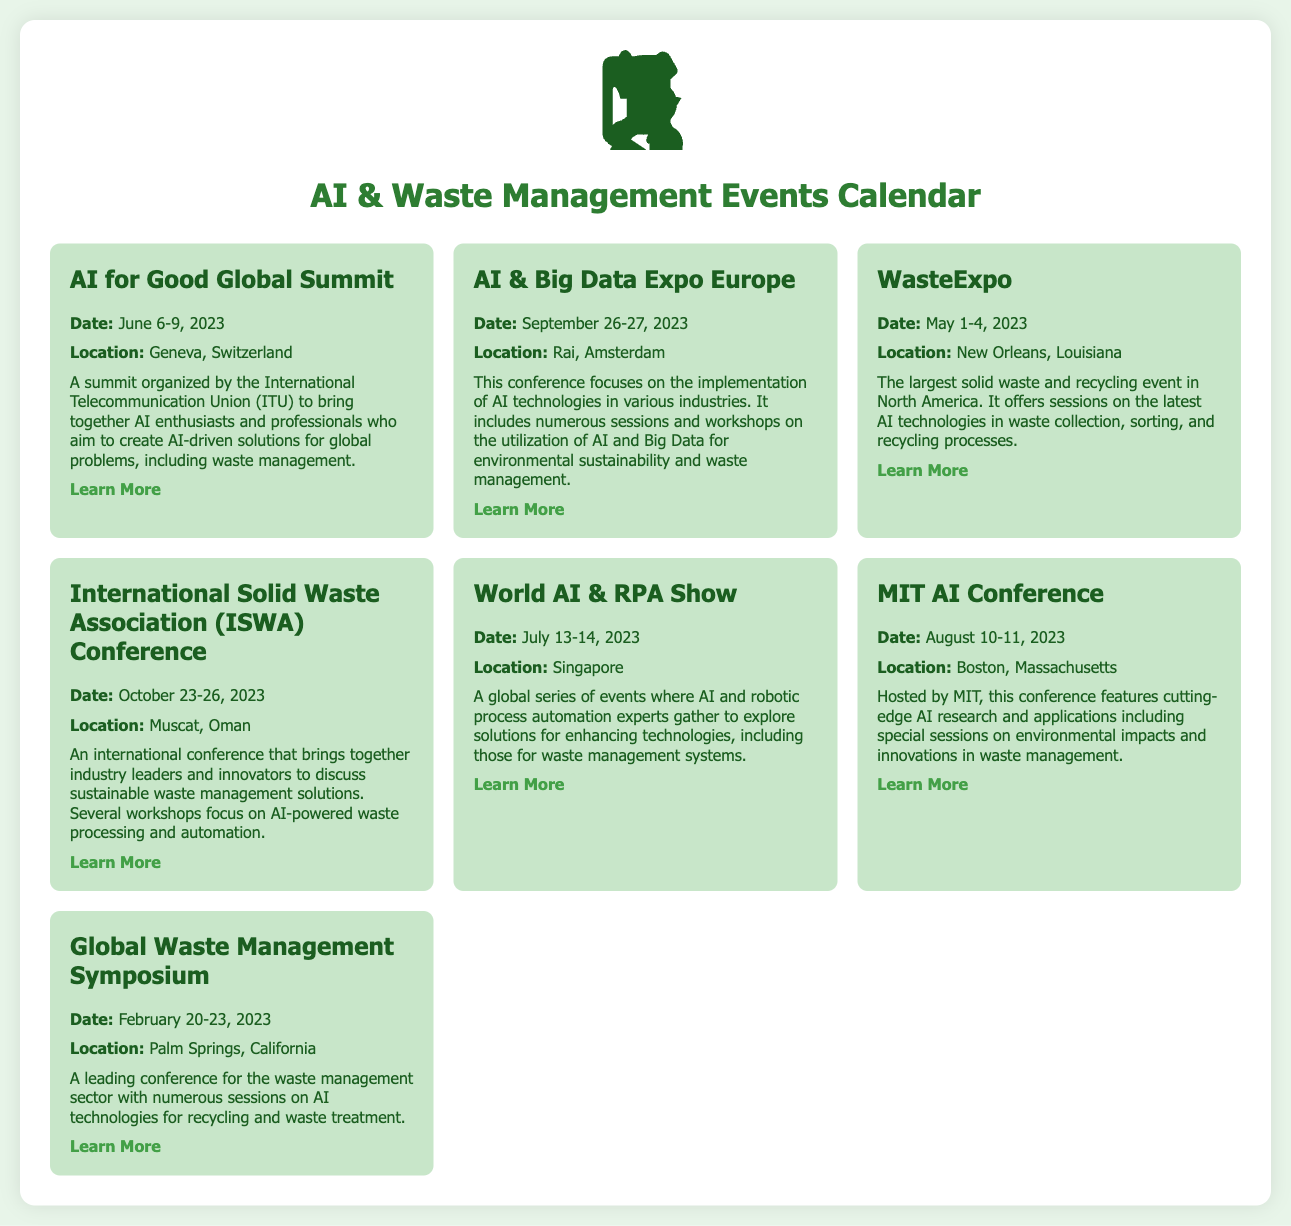What is the date for the AI for Good Global Summit? The date for the AI for Good Global Summit is mentioned as June 6-9, 2023.
Answer: June 6-9, 2023 Where will the International Solid Waste Association (ISWA) Conference be held? The location of the ISWA Conference is specified as Muscat, Oman.
Answer: Muscat, Oman What primary topic is covered at WasteExpo? WasteExpo covers the latest AI technologies in waste collection, sorting, and recycling processes.
Answer: AI technologies in waste collection, sorting, and recycling How many events are listed in the calendar? The total number of events listed in the calendar can be counted as seven.
Answer: Seven What organization is behind the AI for Good Global Summit? The summit is organized by the International Telecommunication Union (ITU).
Answer: International Telecommunication Union (ITU) Which event focuses on AI research and applications hosted by MIT? The event focusing on AI research hosted by MIT is the MIT AI Conference.
Answer: MIT AI Conference What is the date of the AI & Big Data Expo Europe? The AI & Big Data Expo Europe is scheduled for September 26-27, 2023.
Answer: September 26-27, 2023 Which event occurs in Singapore? The event that occurs in Singapore is the World AI & RPA Show.
Answer: World AI & RPA Show What is the main focus of the Global Waste Management Symposium? The main focus of the Global Waste Management Symposium is on AI technologies for recycling and waste treatment.
Answer: AI technologies for recycling and waste treatment 